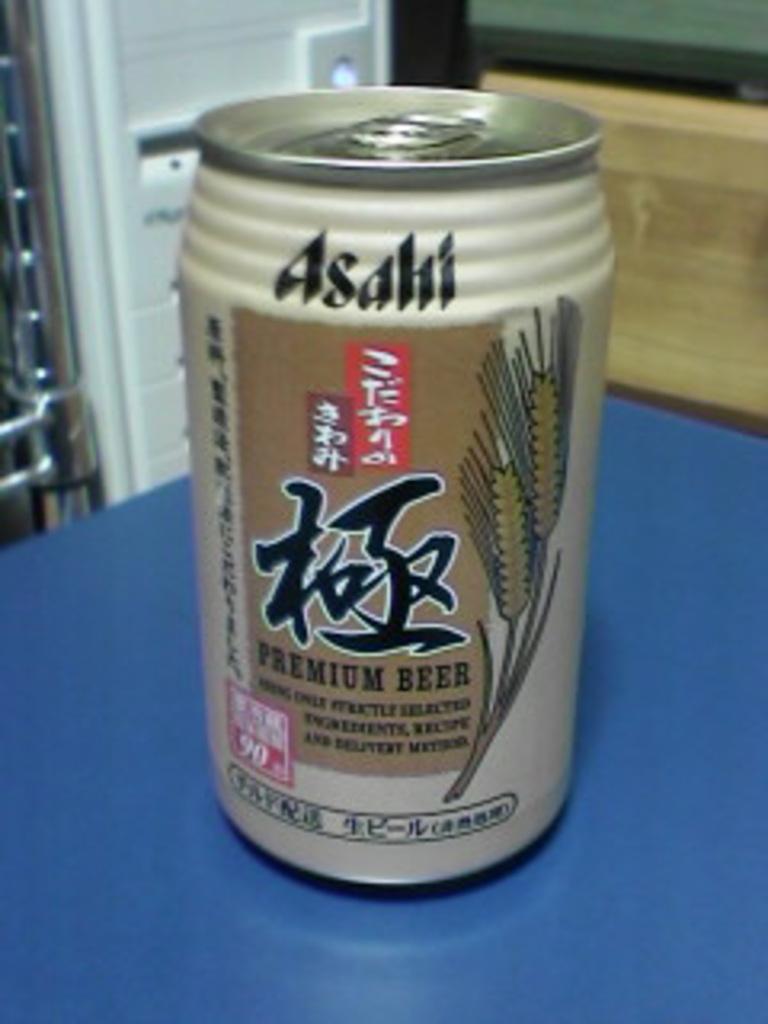Please provide a concise description of this image. In the picture I can see a coke tin on the table. 